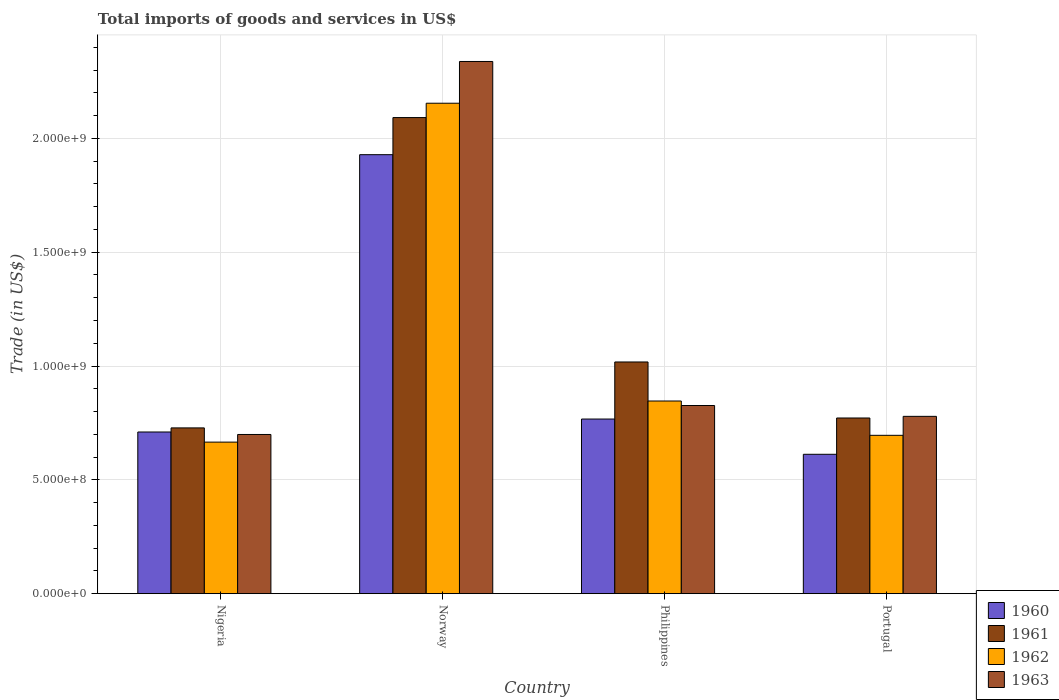How many different coloured bars are there?
Give a very brief answer. 4. How many groups of bars are there?
Offer a terse response. 4. What is the label of the 2nd group of bars from the left?
Offer a very short reply. Norway. In how many cases, is the number of bars for a given country not equal to the number of legend labels?
Provide a short and direct response. 0. What is the total imports of goods and services in 1962 in Nigeria?
Ensure brevity in your answer.  6.66e+08. Across all countries, what is the maximum total imports of goods and services in 1961?
Ensure brevity in your answer.  2.09e+09. Across all countries, what is the minimum total imports of goods and services in 1960?
Offer a terse response. 6.12e+08. In which country was the total imports of goods and services in 1962 minimum?
Your response must be concise. Nigeria. What is the total total imports of goods and services in 1961 in the graph?
Offer a very short reply. 4.61e+09. What is the difference between the total imports of goods and services in 1962 in Nigeria and that in Portugal?
Offer a terse response. -2.99e+07. What is the difference between the total imports of goods and services in 1963 in Philippines and the total imports of goods and services in 1962 in Norway?
Keep it short and to the point. -1.33e+09. What is the average total imports of goods and services in 1962 per country?
Your answer should be compact. 1.09e+09. What is the difference between the total imports of goods and services of/in 1961 and total imports of goods and services of/in 1963 in Norway?
Offer a terse response. -2.46e+08. In how many countries, is the total imports of goods and services in 1961 greater than 2000000000 US$?
Offer a very short reply. 1. What is the ratio of the total imports of goods and services in 1963 in Philippines to that in Portugal?
Your answer should be compact. 1.06. Is the total imports of goods and services in 1963 in Nigeria less than that in Portugal?
Provide a succinct answer. Yes. What is the difference between the highest and the second highest total imports of goods and services in 1961?
Provide a succinct answer. 1.32e+09. What is the difference between the highest and the lowest total imports of goods and services in 1963?
Offer a very short reply. 1.64e+09. Is it the case that in every country, the sum of the total imports of goods and services in 1960 and total imports of goods and services in 1961 is greater than the sum of total imports of goods and services in 1962 and total imports of goods and services in 1963?
Ensure brevity in your answer.  No. What does the 1st bar from the right in Nigeria represents?
Your response must be concise. 1963. Is it the case that in every country, the sum of the total imports of goods and services in 1963 and total imports of goods and services in 1960 is greater than the total imports of goods and services in 1961?
Your answer should be compact. Yes. How many bars are there?
Offer a terse response. 16. Are all the bars in the graph horizontal?
Keep it short and to the point. No. What is the difference between two consecutive major ticks on the Y-axis?
Offer a very short reply. 5.00e+08. Does the graph contain grids?
Make the answer very short. Yes. Where does the legend appear in the graph?
Make the answer very short. Bottom right. How are the legend labels stacked?
Ensure brevity in your answer.  Vertical. What is the title of the graph?
Give a very brief answer. Total imports of goods and services in US$. Does "1964" appear as one of the legend labels in the graph?
Keep it short and to the point. No. What is the label or title of the X-axis?
Your answer should be very brief. Country. What is the label or title of the Y-axis?
Offer a very short reply. Trade (in US$). What is the Trade (in US$) in 1960 in Nigeria?
Provide a short and direct response. 7.10e+08. What is the Trade (in US$) of 1961 in Nigeria?
Make the answer very short. 7.28e+08. What is the Trade (in US$) of 1962 in Nigeria?
Provide a short and direct response. 6.66e+08. What is the Trade (in US$) of 1963 in Nigeria?
Give a very brief answer. 6.99e+08. What is the Trade (in US$) of 1960 in Norway?
Provide a short and direct response. 1.93e+09. What is the Trade (in US$) of 1961 in Norway?
Your answer should be compact. 2.09e+09. What is the Trade (in US$) in 1962 in Norway?
Your answer should be very brief. 2.15e+09. What is the Trade (in US$) in 1963 in Norway?
Provide a short and direct response. 2.34e+09. What is the Trade (in US$) in 1960 in Philippines?
Keep it short and to the point. 7.67e+08. What is the Trade (in US$) of 1961 in Philippines?
Provide a succinct answer. 1.02e+09. What is the Trade (in US$) in 1962 in Philippines?
Offer a very short reply. 8.46e+08. What is the Trade (in US$) in 1963 in Philippines?
Keep it short and to the point. 8.27e+08. What is the Trade (in US$) in 1960 in Portugal?
Offer a terse response. 6.12e+08. What is the Trade (in US$) in 1961 in Portugal?
Your response must be concise. 7.72e+08. What is the Trade (in US$) of 1962 in Portugal?
Keep it short and to the point. 6.96e+08. What is the Trade (in US$) in 1963 in Portugal?
Keep it short and to the point. 7.79e+08. Across all countries, what is the maximum Trade (in US$) in 1960?
Provide a short and direct response. 1.93e+09. Across all countries, what is the maximum Trade (in US$) in 1961?
Your answer should be very brief. 2.09e+09. Across all countries, what is the maximum Trade (in US$) of 1962?
Give a very brief answer. 2.15e+09. Across all countries, what is the maximum Trade (in US$) in 1963?
Give a very brief answer. 2.34e+09. Across all countries, what is the minimum Trade (in US$) in 1960?
Ensure brevity in your answer.  6.12e+08. Across all countries, what is the minimum Trade (in US$) in 1961?
Keep it short and to the point. 7.28e+08. Across all countries, what is the minimum Trade (in US$) of 1962?
Your answer should be very brief. 6.66e+08. Across all countries, what is the minimum Trade (in US$) in 1963?
Offer a terse response. 6.99e+08. What is the total Trade (in US$) in 1960 in the graph?
Provide a short and direct response. 4.02e+09. What is the total Trade (in US$) of 1961 in the graph?
Give a very brief answer. 4.61e+09. What is the total Trade (in US$) of 1962 in the graph?
Keep it short and to the point. 4.36e+09. What is the total Trade (in US$) in 1963 in the graph?
Your answer should be very brief. 4.64e+09. What is the difference between the Trade (in US$) in 1960 in Nigeria and that in Norway?
Ensure brevity in your answer.  -1.22e+09. What is the difference between the Trade (in US$) of 1961 in Nigeria and that in Norway?
Provide a short and direct response. -1.36e+09. What is the difference between the Trade (in US$) of 1962 in Nigeria and that in Norway?
Your answer should be compact. -1.49e+09. What is the difference between the Trade (in US$) of 1963 in Nigeria and that in Norway?
Provide a short and direct response. -1.64e+09. What is the difference between the Trade (in US$) of 1960 in Nigeria and that in Philippines?
Keep it short and to the point. -5.69e+07. What is the difference between the Trade (in US$) in 1961 in Nigeria and that in Philippines?
Provide a short and direct response. -2.90e+08. What is the difference between the Trade (in US$) of 1962 in Nigeria and that in Philippines?
Provide a short and direct response. -1.81e+08. What is the difference between the Trade (in US$) in 1963 in Nigeria and that in Philippines?
Offer a terse response. -1.27e+08. What is the difference between the Trade (in US$) of 1960 in Nigeria and that in Portugal?
Your response must be concise. 9.79e+07. What is the difference between the Trade (in US$) in 1961 in Nigeria and that in Portugal?
Your answer should be very brief. -4.35e+07. What is the difference between the Trade (in US$) of 1962 in Nigeria and that in Portugal?
Your answer should be compact. -2.99e+07. What is the difference between the Trade (in US$) of 1963 in Nigeria and that in Portugal?
Give a very brief answer. -7.97e+07. What is the difference between the Trade (in US$) of 1960 in Norway and that in Philippines?
Ensure brevity in your answer.  1.16e+09. What is the difference between the Trade (in US$) of 1961 in Norway and that in Philippines?
Your answer should be very brief. 1.07e+09. What is the difference between the Trade (in US$) of 1962 in Norway and that in Philippines?
Your answer should be compact. 1.31e+09. What is the difference between the Trade (in US$) in 1963 in Norway and that in Philippines?
Offer a terse response. 1.51e+09. What is the difference between the Trade (in US$) in 1960 in Norway and that in Portugal?
Your response must be concise. 1.32e+09. What is the difference between the Trade (in US$) in 1961 in Norway and that in Portugal?
Provide a succinct answer. 1.32e+09. What is the difference between the Trade (in US$) in 1962 in Norway and that in Portugal?
Make the answer very short. 1.46e+09. What is the difference between the Trade (in US$) in 1963 in Norway and that in Portugal?
Make the answer very short. 1.56e+09. What is the difference between the Trade (in US$) of 1960 in Philippines and that in Portugal?
Make the answer very short. 1.55e+08. What is the difference between the Trade (in US$) in 1961 in Philippines and that in Portugal?
Make the answer very short. 2.46e+08. What is the difference between the Trade (in US$) in 1962 in Philippines and that in Portugal?
Provide a short and direct response. 1.51e+08. What is the difference between the Trade (in US$) in 1963 in Philippines and that in Portugal?
Give a very brief answer. 4.76e+07. What is the difference between the Trade (in US$) in 1960 in Nigeria and the Trade (in US$) in 1961 in Norway?
Keep it short and to the point. -1.38e+09. What is the difference between the Trade (in US$) of 1960 in Nigeria and the Trade (in US$) of 1962 in Norway?
Your answer should be very brief. -1.44e+09. What is the difference between the Trade (in US$) in 1960 in Nigeria and the Trade (in US$) in 1963 in Norway?
Provide a short and direct response. -1.63e+09. What is the difference between the Trade (in US$) of 1961 in Nigeria and the Trade (in US$) of 1962 in Norway?
Ensure brevity in your answer.  -1.43e+09. What is the difference between the Trade (in US$) of 1961 in Nigeria and the Trade (in US$) of 1963 in Norway?
Give a very brief answer. -1.61e+09. What is the difference between the Trade (in US$) of 1962 in Nigeria and the Trade (in US$) of 1963 in Norway?
Your answer should be compact. -1.67e+09. What is the difference between the Trade (in US$) in 1960 in Nigeria and the Trade (in US$) in 1961 in Philippines?
Provide a short and direct response. -3.08e+08. What is the difference between the Trade (in US$) in 1960 in Nigeria and the Trade (in US$) in 1962 in Philippines?
Make the answer very short. -1.36e+08. What is the difference between the Trade (in US$) in 1960 in Nigeria and the Trade (in US$) in 1963 in Philippines?
Keep it short and to the point. -1.16e+08. What is the difference between the Trade (in US$) in 1961 in Nigeria and the Trade (in US$) in 1962 in Philippines?
Offer a very short reply. -1.18e+08. What is the difference between the Trade (in US$) of 1961 in Nigeria and the Trade (in US$) of 1963 in Philippines?
Provide a succinct answer. -9.84e+07. What is the difference between the Trade (in US$) in 1962 in Nigeria and the Trade (in US$) in 1963 in Philippines?
Your answer should be very brief. -1.61e+08. What is the difference between the Trade (in US$) in 1960 in Nigeria and the Trade (in US$) in 1961 in Portugal?
Your response must be concise. -6.15e+07. What is the difference between the Trade (in US$) in 1960 in Nigeria and the Trade (in US$) in 1962 in Portugal?
Make the answer very short. 1.46e+07. What is the difference between the Trade (in US$) of 1960 in Nigeria and the Trade (in US$) of 1963 in Portugal?
Keep it short and to the point. -6.87e+07. What is the difference between the Trade (in US$) of 1961 in Nigeria and the Trade (in US$) of 1962 in Portugal?
Offer a very short reply. 3.25e+07. What is the difference between the Trade (in US$) of 1961 in Nigeria and the Trade (in US$) of 1963 in Portugal?
Provide a succinct answer. -5.08e+07. What is the difference between the Trade (in US$) in 1962 in Nigeria and the Trade (in US$) in 1963 in Portugal?
Make the answer very short. -1.13e+08. What is the difference between the Trade (in US$) of 1960 in Norway and the Trade (in US$) of 1961 in Philippines?
Your answer should be very brief. 9.11e+08. What is the difference between the Trade (in US$) in 1960 in Norway and the Trade (in US$) in 1962 in Philippines?
Give a very brief answer. 1.08e+09. What is the difference between the Trade (in US$) of 1960 in Norway and the Trade (in US$) of 1963 in Philippines?
Give a very brief answer. 1.10e+09. What is the difference between the Trade (in US$) in 1961 in Norway and the Trade (in US$) in 1962 in Philippines?
Make the answer very short. 1.25e+09. What is the difference between the Trade (in US$) in 1961 in Norway and the Trade (in US$) in 1963 in Philippines?
Offer a terse response. 1.26e+09. What is the difference between the Trade (in US$) in 1962 in Norway and the Trade (in US$) in 1963 in Philippines?
Make the answer very short. 1.33e+09. What is the difference between the Trade (in US$) in 1960 in Norway and the Trade (in US$) in 1961 in Portugal?
Keep it short and to the point. 1.16e+09. What is the difference between the Trade (in US$) in 1960 in Norway and the Trade (in US$) in 1962 in Portugal?
Ensure brevity in your answer.  1.23e+09. What is the difference between the Trade (in US$) of 1960 in Norway and the Trade (in US$) of 1963 in Portugal?
Make the answer very short. 1.15e+09. What is the difference between the Trade (in US$) of 1961 in Norway and the Trade (in US$) of 1962 in Portugal?
Give a very brief answer. 1.40e+09. What is the difference between the Trade (in US$) in 1961 in Norway and the Trade (in US$) in 1963 in Portugal?
Give a very brief answer. 1.31e+09. What is the difference between the Trade (in US$) in 1962 in Norway and the Trade (in US$) in 1963 in Portugal?
Offer a very short reply. 1.38e+09. What is the difference between the Trade (in US$) of 1960 in Philippines and the Trade (in US$) of 1961 in Portugal?
Ensure brevity in your answer.  -4.62e+06. What is the difference between the Trade (in US$) of 1960 in Philippines and the Trade (in US$) of 1962 in Portugal?
Provide a short and direct response. 7.15e+07. What is the difference between the Trade (in US$) in 1960 in Philippines and the Trade (in US$) in 1963 in Portugal?
Make the answer very short. -1.19e+07. What is the difference between the Trade (in US$) in 1961 in Philippines and the Trade (in US$) in 1962 in Portugal?
Offer a terse response. 3.22e+08. What is the difference between the Trade (in US$) of 1961 in Philippines and the Trade (in US$) of 1963 in Portugal?
Provide a succinct answer. 2.39e+08. What is the difference between the Trade (in US$) of 1962 in Philippines and the Trade (in US$) of 1963 in Portugal?
Your answer should be compact. 6.73e+07. What is the average Trade (in US$) of 1960 per country?
Your answer should be compact. 1.00e+09. What is the average Trade (in US$) of 1961 per country?
Your answer should be very brief. 1.15e+09. What is the average Trade (in US$) in 1962 per country?
Offer a very short reply. 1.09e+09. What is the average Trade (in US$) in 1963 per country?
Offer a very short reply. 1.16e+09. What is the difference between the Trade (in US$) of 1960 and Trade (in US$) of 1961 in Nigeria?
Keep it short and to the point. -1.80e+07. What is the difference between the Trade (in US$) of 1960 and Trade (in US$) of 1962 in Nigeria?
Give a very brief answer. 4.45e+07. What is the difference between the Trade (in US$) in 1960 and Trade (in US$) in 1963 in Nigeria?
Your answer should be compact. 1.09e+07. What is the difference between the Trade (in US$) of 1961 and Trade (in US$) of 1962 in Nigeria?
Provide a succinct answer. 6.24e+07. What is the difference between the Trade (in US$) of 1961 and Trade (in US$) of 1963 in Nigeria?
Provide a succinct answer. 2.89e+07. What is the difference between the Trade (in US$) in 1962 and Trade (in US$) in 1963 in Nigeria?
Ensure brevity in your answer.  -3.35e+07. What is the difference between the Trade (in US$) of 1960 and Trade (in US$) of 1961 in Norway?
Keep it short and to the point. -1.63e+08. What is the difference between the Trade (in US$) of 1960 and Trade (in US$) of 1962 in Norway?
Keep it short and to the point. -2.26e+08. What is the difference between the Trade (in US$) in 1960 and Trade (in US$) in 1963 in Norway?
Ensure brevity in your answer.  -4.09e+08. What is the difference between the Trade (in US$) in 1961 and Trade (in US$) in 1962 in Norway?
Provide a short and direct response. -6.31e+07. What is the difference between the Trade (in US$) of 1961 and Trade (in US$) of 1963 in Norway?
Give a very brief answer. -2.46e+08. What is the difference between the Trade (in US$) of 1962 and Trade (in US$) of 1963 in Norway?
Make the answer very short. -1.83e+08. What is the difference between the Trade (in US$) of 1960 and Trade (in US$) of 1961 in Philippines?
Provide a short and direct response. -2.51e+08. What is the difference between the Trade (in US$) in 1960 and Trade (in US$) in 1962 in Philippines?
Provide a succinct answer. -7.92e+07. What is the difference between the Trade (in US$) of 1960 and Trade (in US$) of 1963 in Philippines?
Offer a very short reply. -5.95e+07. What is the difference between the Trade (in US$) of 1961 and Trade (in US$) of 1962 in Philippines?
Provide a succinct answer. 1.72e+08. What is the difference between the Trade (in US$) in 1961 and Trade (in US$) in 1963 in Philippines?
Your response must be concise. 1.91e+08. What is the difference between the Trade (in US$) in 1962 and Trade (in US$) in 1963 in Philippines?
Provide a succinct answer. 1.97e+07. What is the difference between the Trade (in US$) of 1960 and Trade (in US$) of 1961 in Portugal?
Your answer should be compact. -1.59e+08. What is the difference between the Trade (in US$) in 1960 and Trade (in US$) in 1962 in Portugal?
Keep it short and to the point. -8.33e+07. What is the difference between the Trade (in US$) in 1960 and Trade (in US$) in 1963 in Portugal?
Your answer should be compact. -1.67e+08. What is the difference between the Trade (in US$) in 1961 and Trade (in US$) in 1962 in Portugal?
Your answer should be very brief. 7.61e+07. What is the difference between the Trade (in US$) in 1961 and Trade (in US$) in 1963 in Portugal?
Offer a terse response. -7.25e+06. What is the difference between the Trade (in US$) of 1962 and Trade (in US$) of 1963 in Portugal?
Keep it short and to the point. -8.33e+07. What is the ratio of the Trade (in US$) in 1960 in Nigeria to that in Norway?
Give a very brief answer. 0.37. What is the ratio of the Trade (in US$) in 1961 in Nigeria to that in Norway?
Offer a terse response. 0.35. What is the ratio of the Trade (in US$) in 1962 in Nigeria to that in Norway?
Offer a very short reply. 0.31. What is the ratio of the Trade (in US$) in 1963 in Nigeria to that in Norway?
Offer a very short reply. 0.3. What is the ratio of the Trade (in US$) of 1960 in Nigeria to that in Philippines?
Make the answer very short. 0.93. What is the ratio of the Trade (in US$) in 1961 in Nigeria to that in Philippines?
Offer a terse response. 0.72. What is the ratio of the Trade (in US$) in 1962 in Nigeria to that in Philippines?
Your answer should be very brief. 0.79. What is the ratio of the Trade (in US$) of 1963 in Nigeria to that in Philippines?
Keep it short and to the point. 0.85. What is the ratio of the Trade (in US$) of 1960 in Nigeria to that in Portugal?
Provide a short and direct response. 1.16. What is the ratio of the Trade (in US$) in 1961 in Nigeria to that in Portugal?
Your answer should be compact. 0.94. What is the ratio of the Trade (in US$) in 1963 in Nigeria to that in Portugal?
Your answer should be very brief. 0.9. What is the ratio of the Trade (in US$) of 1960 in Norway to that in Philippines?
Make the answer very short. 2.51. What is the ratio of the Trade (in US$) in 1961 in Norway to that in Philippines?
Give a very brief answer. 2.05. What is the ratio of the Trade (in US$) of 1962 in Norway to that in Philippines?
Make the answer very short. 2.55. What is the ratio of the Trade (in US$) of 1963 in Norway to that in Philippines?
Your response must be concise. 2.83. What is the ratio of the Trade (in US$) of 1960 in Norway to that in Portugal?
Offer a very short reply. 3.15. What is the ratio of the Trade (in US$) in 1961 in Norway to that in Portugal?
Offer a terse response. 2.71. What is the ratio of the Trade (in US$) in 1962 in Norway to that in Portugal?
Offer a very short reply. 3.1. What is the ratio of the Trade (in US$) in 1963 in Norway to that in Portugal?
Offer a terse response. 3. What is the ratio of the Trade (in US$) in 1960 in Philippines to that in Portugal?
Ensure brevity in your answer.  1.25. What is the ratio of the Trade (in US$) in 1961 in Philippines to that in Portugal?
Offer a terse response. 1.32. What is the ratio of the Trade (in US$) of 1962 in Philippines to that in Portugal?
Your answer should be very brief. 1.22. What is the ratio of the Trade (in US$) in 1963 in Philippines to that in Portugal?
Provide a short and direct response. 1.06. What is the difference between the highest and the second highest Trade (in US$) in 1960?
Provide a short and direct response. 1.16e+09. What is the difference between the highest and the second highest Trade (in US$) in 1961?
Your answer should be very brief. 1.07e+09. What is the difference between the highest and the second highest Trade (in US$) in 1962?
Keep it short and to the point. 1.31e+09. What is the difference between the highest and the second highest Trade (in US$) in 1963?
Ensure brevity in your answer.  1.51e+09. What is the difference between the highest and the lowest Trade (in US$) of 1960?
Your answer should be compact. 1.32e+09. What is the difference between the highest and the lowest Trade (in US$) in 1961?
Provide a succinct answer. 1.36e+09. What is the difference between the highest and the lowest Trade (in US$) of 1962?
Keep it short and to the point. 1.49e+09. What is the difference between the highest and the lowest Trade (in US$) in 1963?
Offer a terse response. 1.64e+09. 